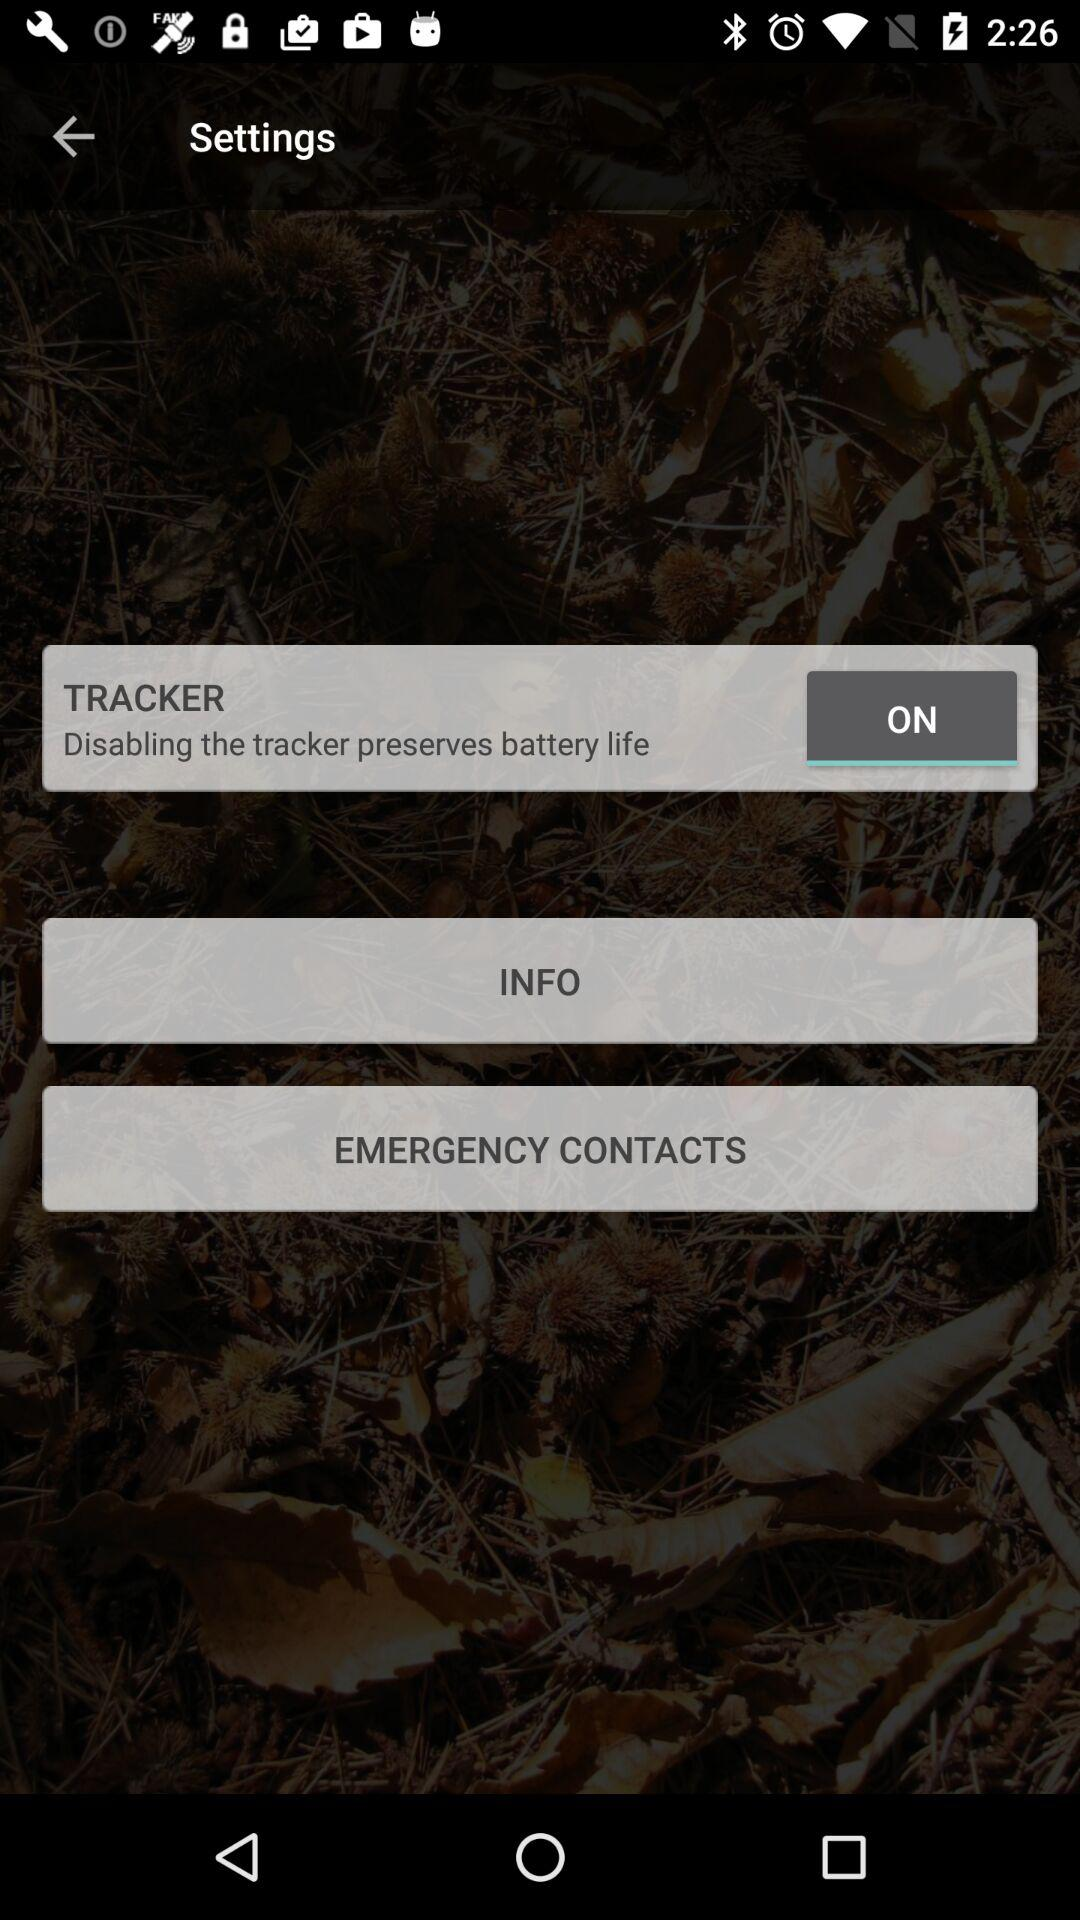What is the status of the tracker? The status of the tracker is on. 